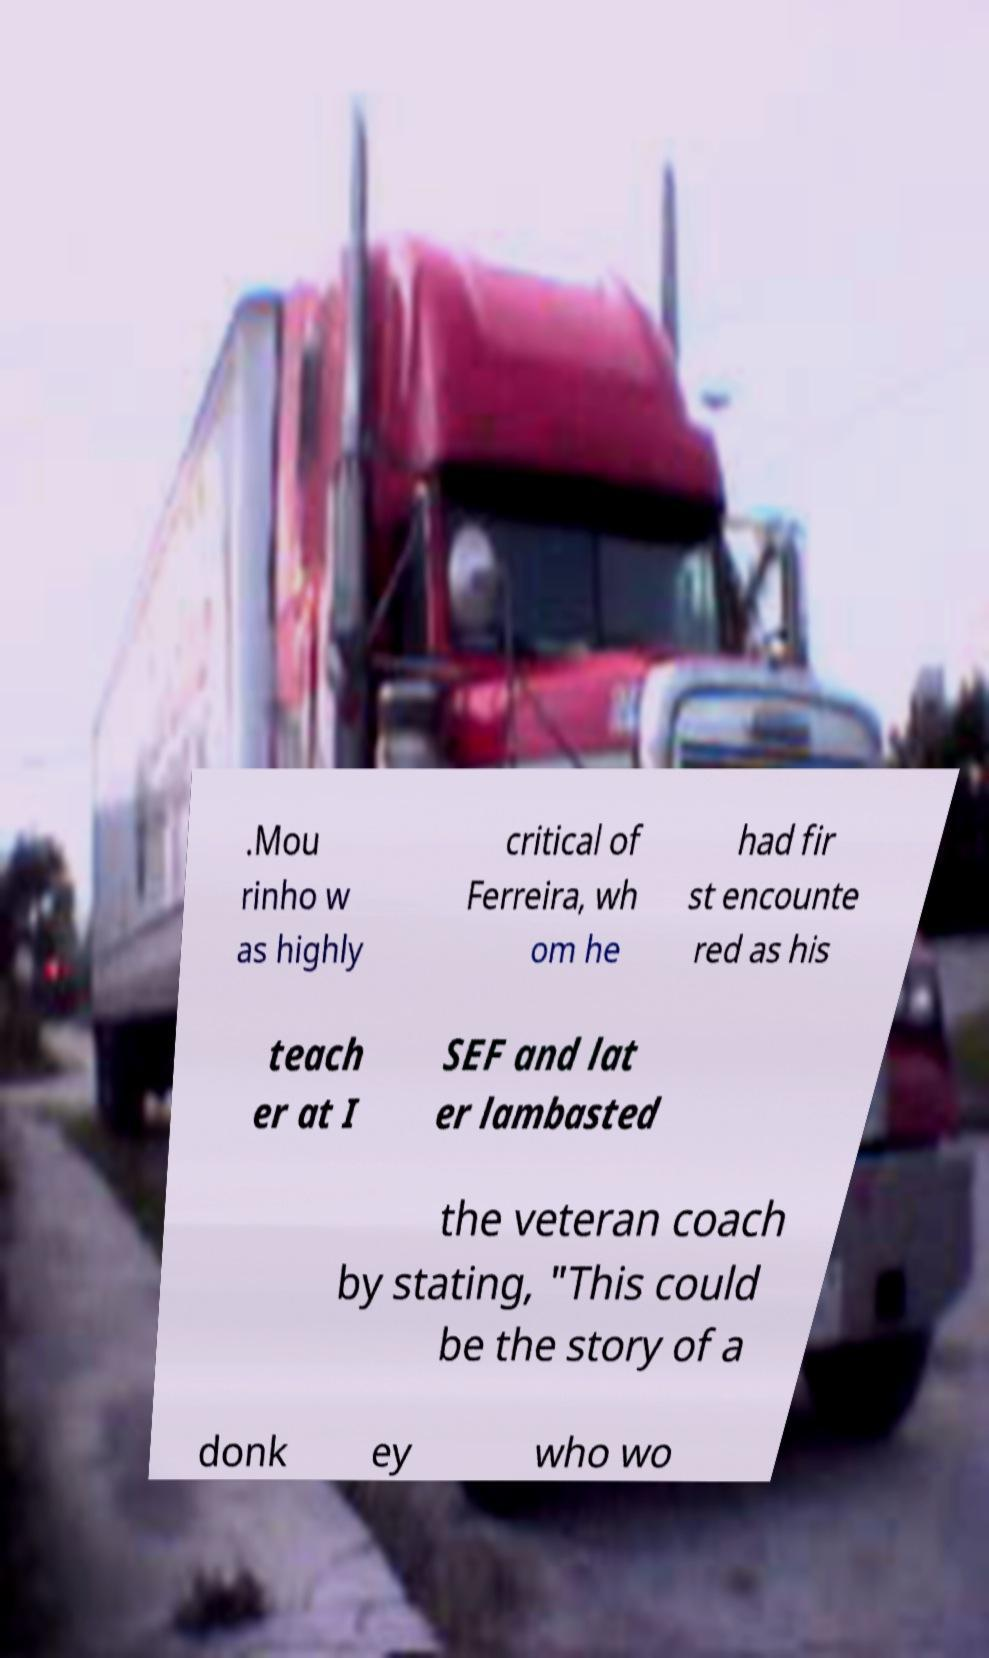Can you read and provide the text displayed in the image?This photo seems to have some interesting text. Can you extract and type it out for me? .Mou rinho w as highly critical of Ferreira, wh om he had fir st encounte red as his teach er at I SEF and lat er lambasted the veteran coach by stating, "This could be the story of a donk ey who wo 